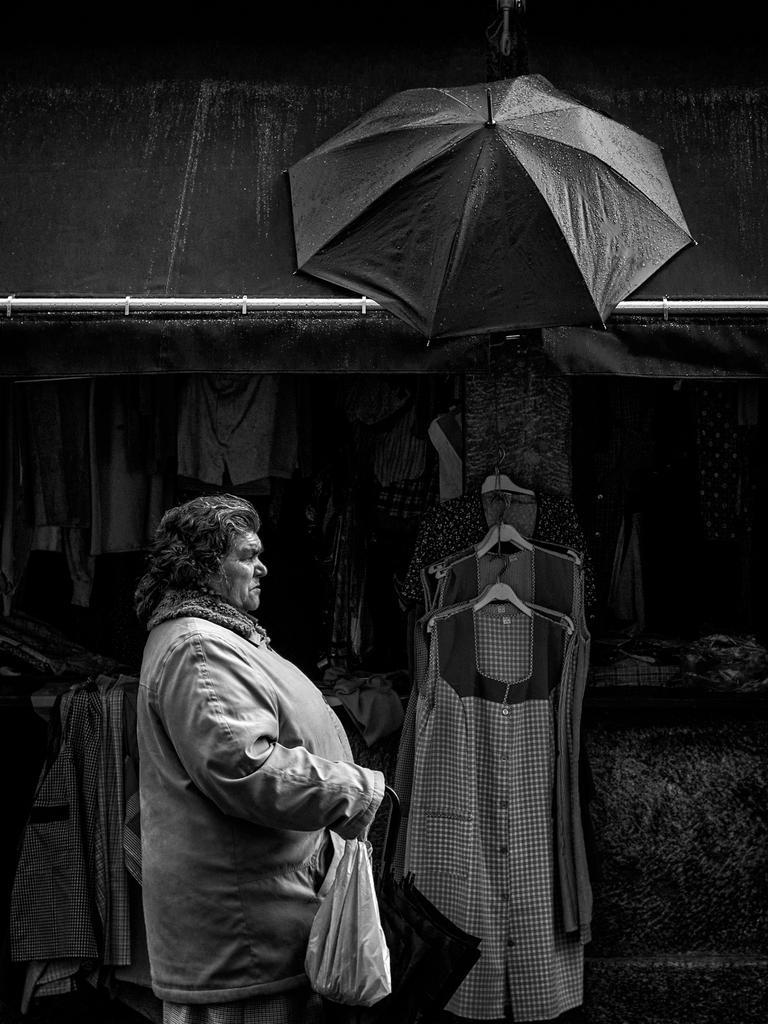How would you summarize this image in a sentence or two? In this image we can see a lady person wearing jacket holding umbrella and some carry bag in her hands and in the background of the image there are some clothes hanged and some are arranged in shelves and top of the image we can see tent and umbrella. 